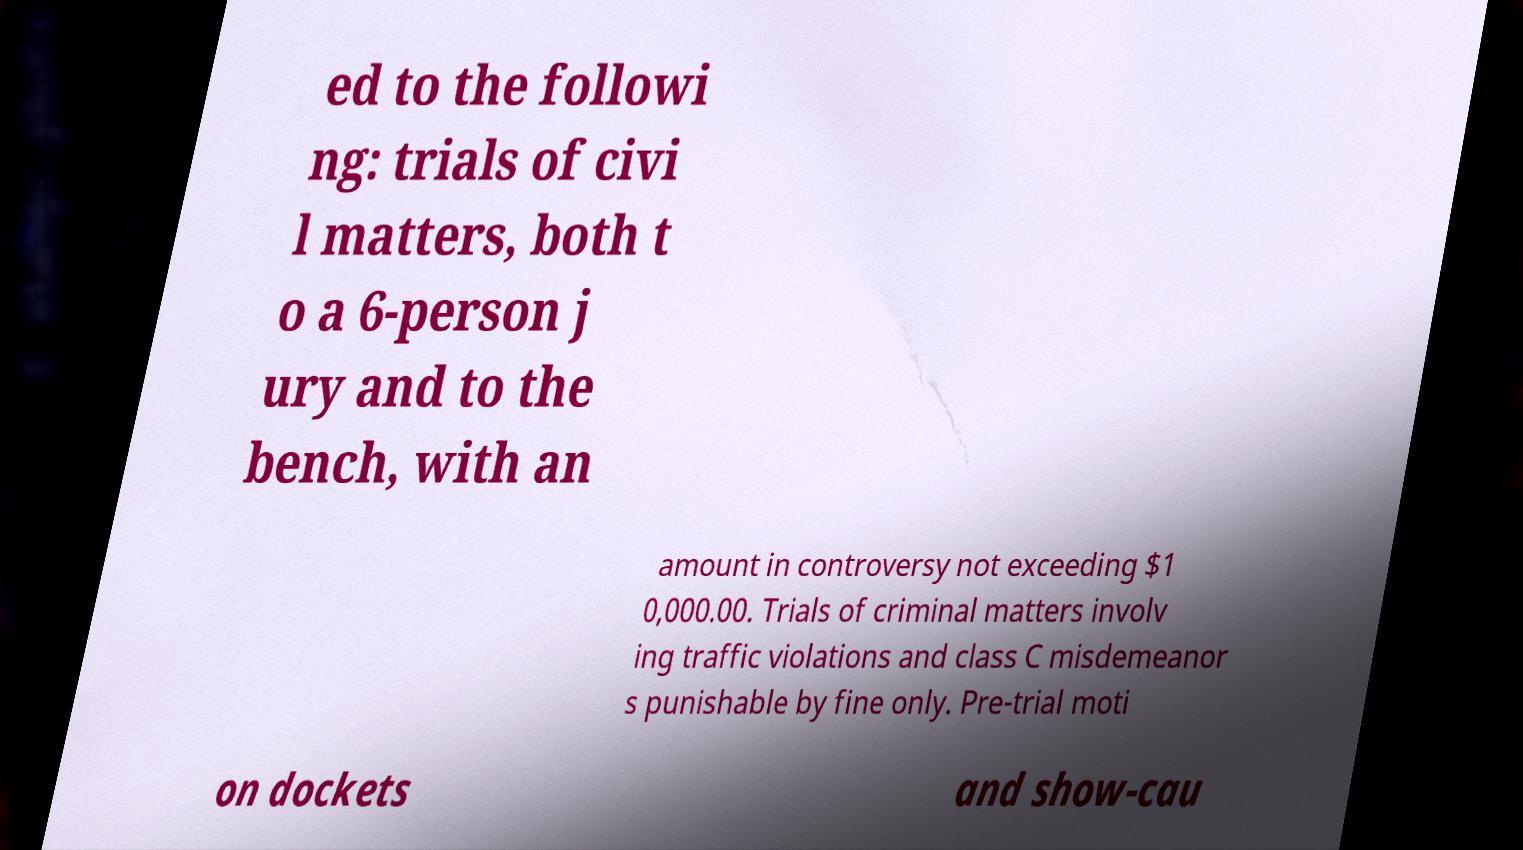Please identify and transcribe the text found in this image. ed to the followi ng: trials of civi l matters, both t o a 6-person j ury and to the bench, with an amount in controversy not exceeding $1 0,000.00. Trials of criminal matters involv ing traffic violations and class C misdemeanor s punishable by fine only. Pre-trial moti on dockets and show-cau 